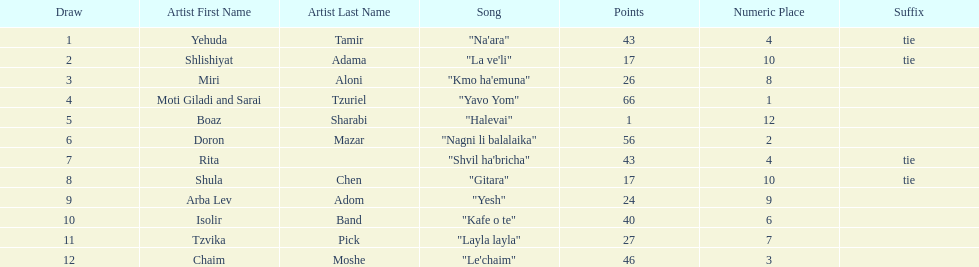Who were all the artists at the contest? Yehuda Tamir, Shlishiyat Adama, Miri Aloni, Moti Giladi and Sarai Tzuriel, Boaz Sharabi, Doron Mazar, Rita, Shula Chen, Arba Lev Adom, Isolir Band, Tzvika Pick, Chaim Moshe. What were their point totals? 43, 17, 26, 66, 1, 56, 43, 17, 24, 40, 27, 46. Of these, which is the least amount of points? 1. Which artists received this point total? Boaz Sharabi. 